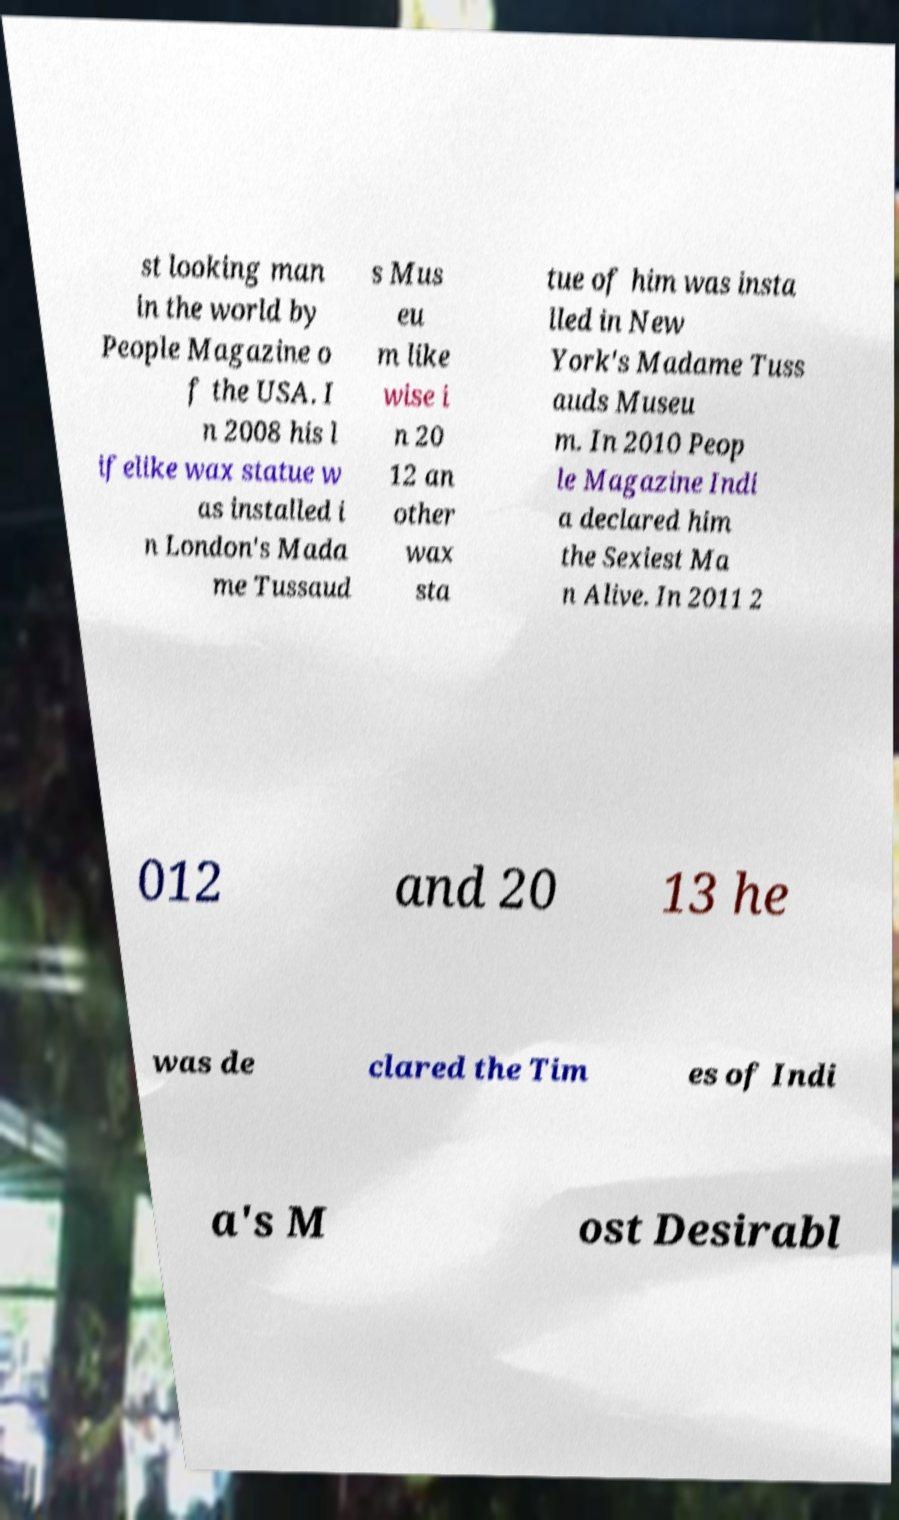Could you extract and type out the text from this image? st looking man in the world by People Magazine o f the USA. I n 2008 his l ifelike wax statue w as installed i n London's Mada me Tussaud s Mus eu m like wise i n 20 12 an other wax sta tue of him was insta lled in New York's Madame Tuss auds Museu m. In 2010 Peop le Magazine Indi a declared him the Sexiest Ma n Alive. In 2011 2 012 and 20 13 he was de clared the Tim es of Indi a's M ost Desirabl 